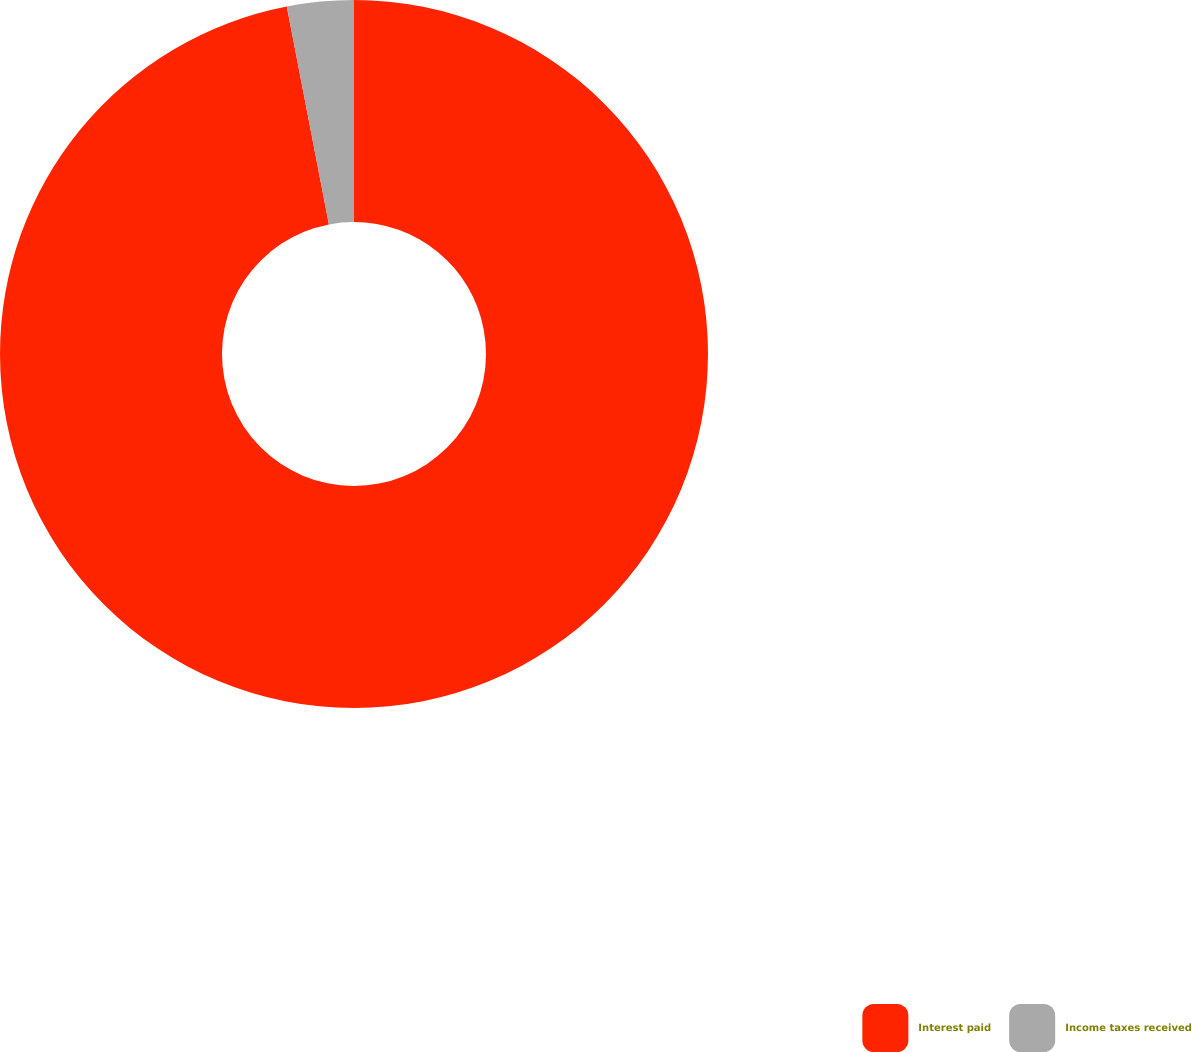Convert chart to OTSL. <chart><loc_0><loc_0><loc_500><loc_500><pie_chart><fcel>Interest paid<fcel>Income taxes received<nl><fcel>96.96%<fcel>3.04%<nl></chart> 